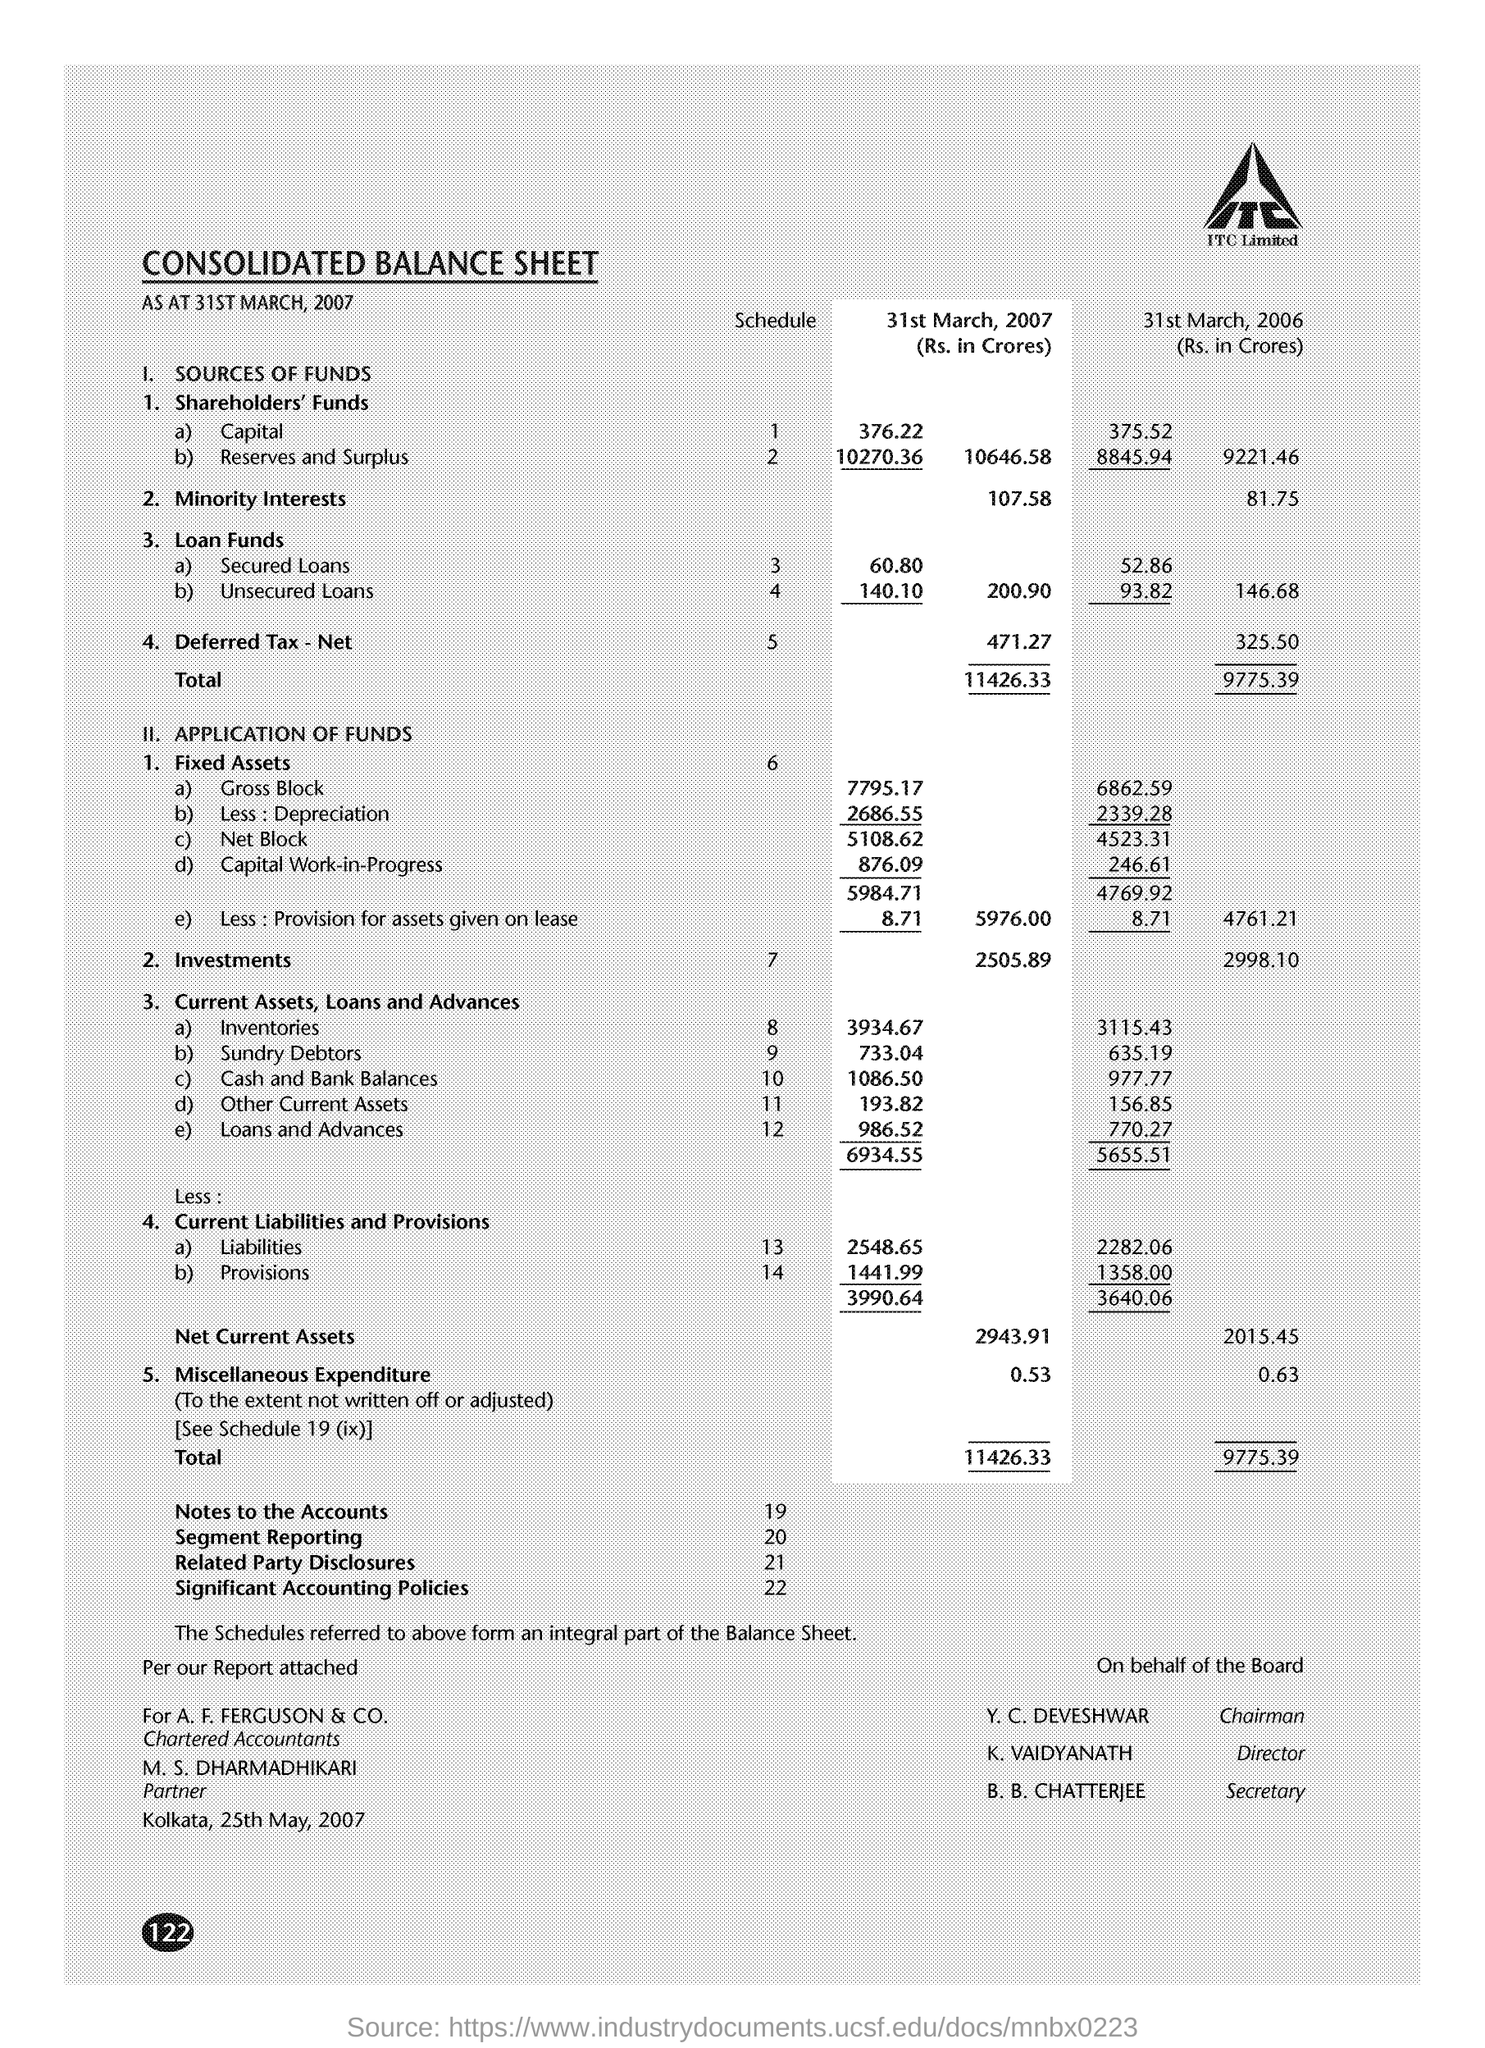Give some essential details in this illustration. On March 31st, 2006, the investments were 2998.10... The net current assets for 31st March 2007 were 2943.91. The title of the document is 'Consolidated Balance Sheet.' On March 31, 2007, the investments were 2505.89. The place name mentioned on the document is Kolkata. 